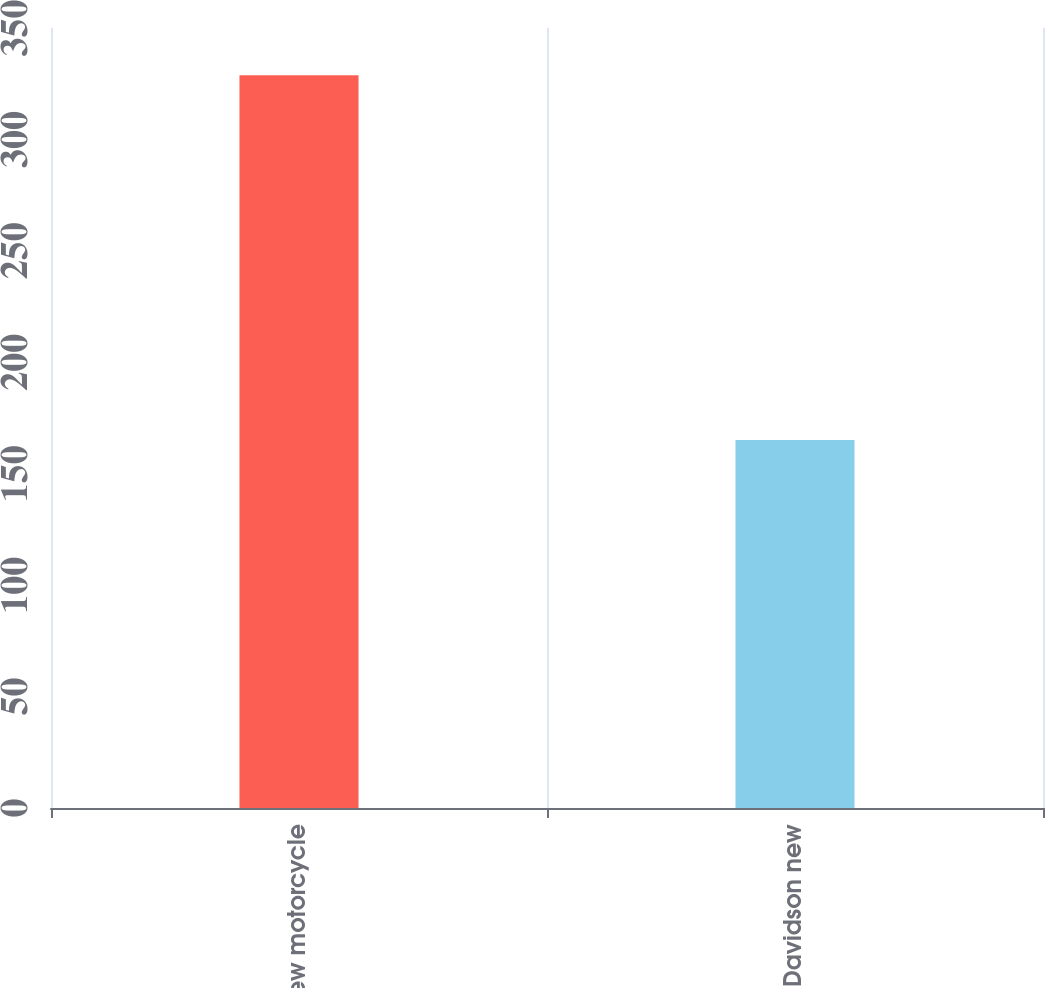Convert chart to OTSL. <chart><loc_0><loc_0><loc_500><loc_500><bar_chart><fcel>Total new motorcycle<fcel>Harley-Davidson new<nl><fcel>328.8<fcel>165.1<nl></chart> 